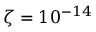Convert formula to latex. <formula><loc_0><loc_0><loc_500><loc_500>\zeta = 1 0 ^ { - 1 4 }</formula> 